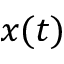<formula> <loc_0><loc_0><loc_500><loc_500>x ( t )</formula> 